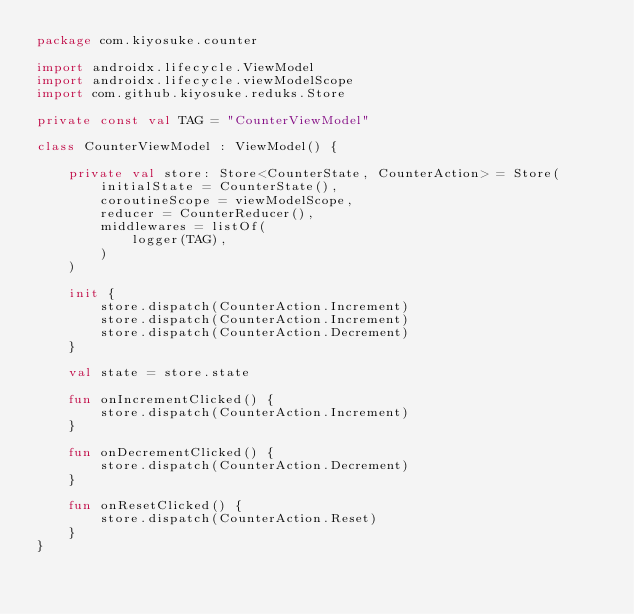<code> <loc_0><loc_0><loc_500><loc_500><_Kotlin_>package com.kiyosuke.counter

import androidx.lifecycle.ViewModel
import androidx.lifecycle.viewModelScope
import com.github.kiyosuke.reduks.Store

private const val TAG = "CounterViewModel"

class CounterViewModel : ViewModel() {

    private val store: Store<CounterState, CounterAction> = Store(
        initialState = CounterState(),
        coroutineScope = viewModelScope,
        reducer = CounterReducer(),
        middlewares = listOf(
            logger(TAG),
        )
    )

    init {
        store.dispatch(CounterAction.Increment)
        store.dispatch(CounterAction.Increment)
        store.dispatch(CounterAction.Decrement)
    }

    val state = store.state

    fun onIncrementClicked() {
        store.dispatch(CounterAction.Increment)
    }

    fun onDecrementClicked() {
        store.dispatch(CounterAction.Decrement)
    }

    fun onResetClicked() {
        store.dispatch(CounterAction.Reset)
    }
}
</code> 